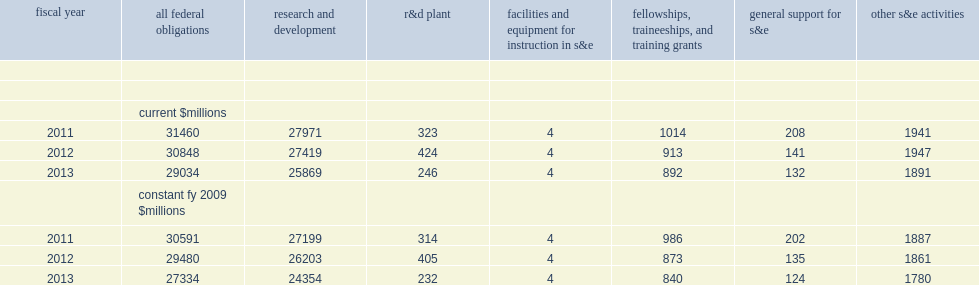After adjustment for inflation, how many million dollars did federal s&e obligations to academic institutions declin from fy 2011 to fy 2012? 1111. After adjustment for inflation, how many percent did federal s&e obligations to academic institutions decline between fy 2011 and fy 2012? 0.036318. After adjustment for inflation, how many million dollars did federal s&e obligations to academic institutions declin from fy 2012 to fy 2013? 2146. After adjustment for inflation, how many percent did federal s&e obligations to academic institutions decline between fy 2012 and fy 2013? 0.072795. How many percent did federal s&e obligations to academic institutions decline between fy 2012 and fy 2013? 2146. How many billion dollars did federal s&e obligations to academic institutions declin from fy 2012 to fy 2013? 0.072795. 